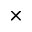Convert formula to latex. <formula><loc_0><loc_0><loc_500><loc_500>\times</formula> 